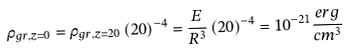Convert formula to latex. <formula><loc_0><loc_0><loc_500><loc_500>\rho _ { g r , z = 0 } = \rho _ { g r , z = 2 0 } \left ( { 2 0 } \right ) ^ { - 4 } = \frac { E } { R ^ { 3 } } \left ( { 2 0 } \right ) ^ { - 4 } = 1 0 ^ { - 2 1 } \frac { e r g } { c m ^ { 3 } }</formula> 